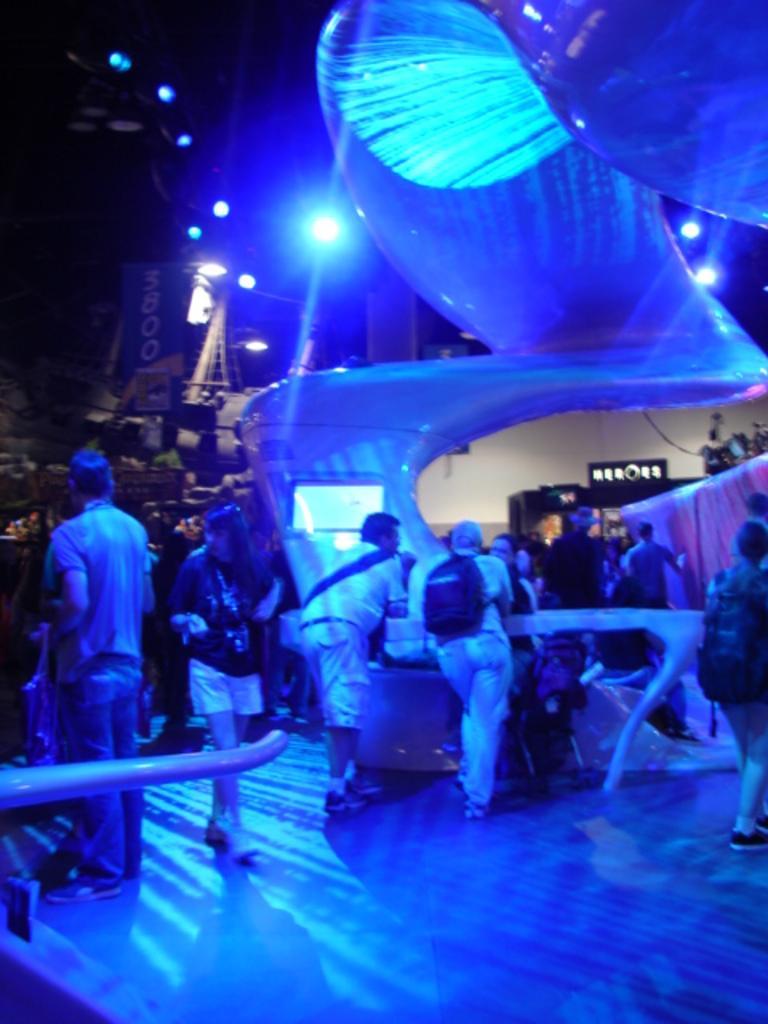In one or two sentences, can you explain what this image depicts? In the picture we can see some group of persons standing and some are walking under blue lights. 